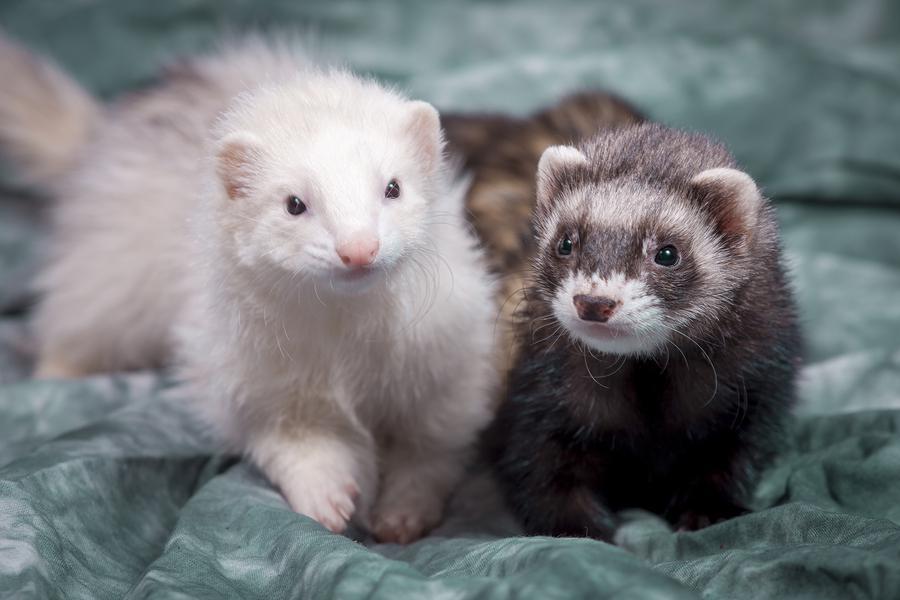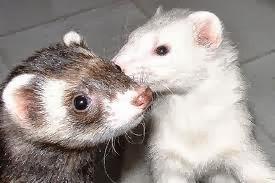The first image is the image on the left, the second image is the image on the right. Given the left and right images, does the statement "Someone is holding at least one of the animals." hold true? Answer yes or no. No. 